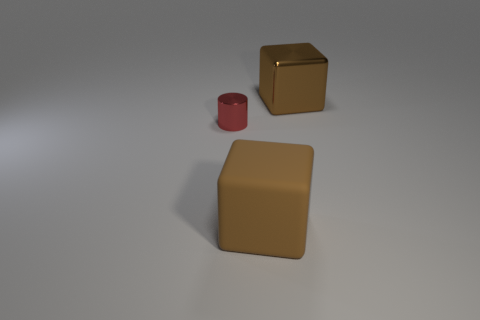Add 2 matte cylinders. How many objects exist? 5 Subtract all blocks. How many objects are left? 1 Subtract all blue cylinders. Subtract all red metal cylinders. How many objects are left? 2 Add 3 brown objects. How many brown objects are left? 5 Add 3 big gray matte blocks. How many big gray matte blocks exist? 3 Subtract 0 brown cylinders. How many objects are left? 3 